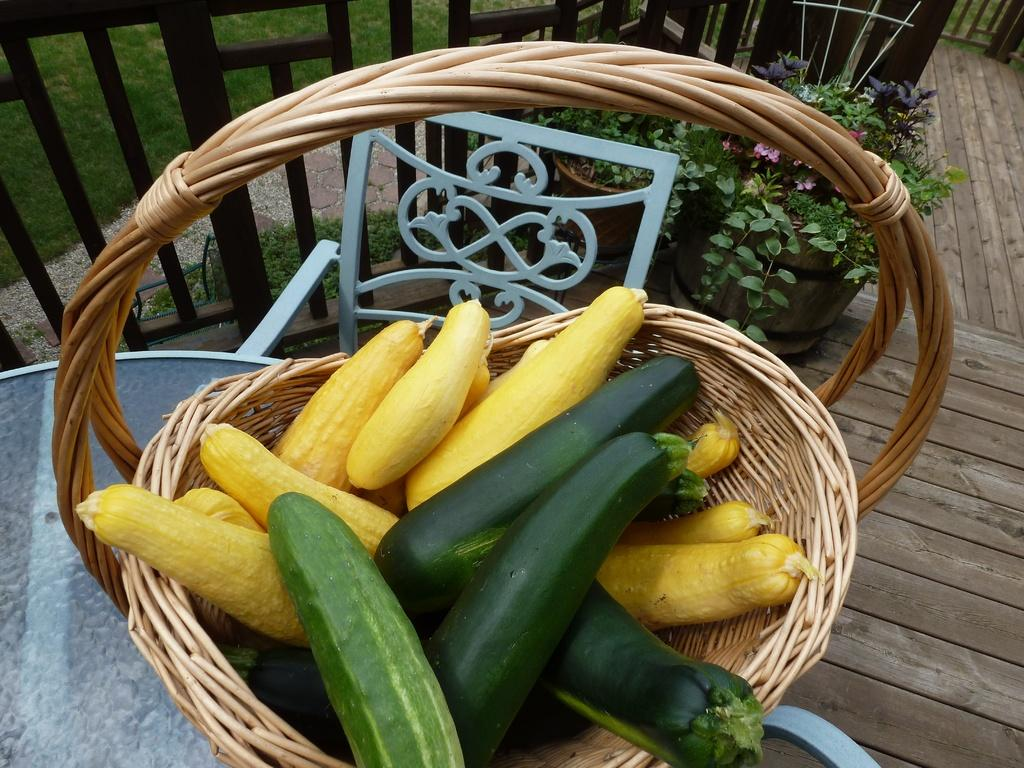What type of food items are in the basket in the image? There are vegetables in a basket in the image. Where is the basket located? The basket is on a table. What is behind the basket on the table? There is a chair behind the basket. What architectural feature can be seen in the image? Iron grilles are visible in the image. What type of natural environment is present in the image? There is grass in the image. Are there any plants in the image? Yes, there are plants in pots in the image. What type of reaction can be seen from the vegetables in the image? There is no reaction from the vegetables in the image, as they are inanimate objects. 